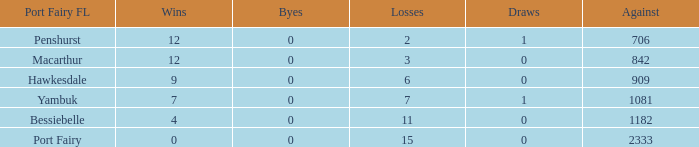For port fairy, how many wins exceed the count of 2333? None. 